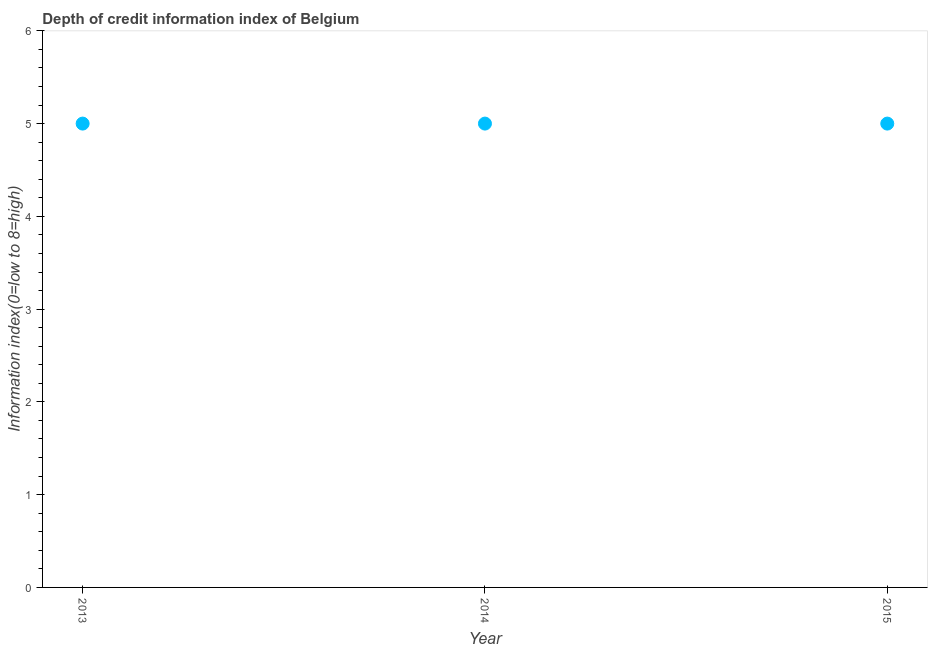What is the depth of credit information index in 2014?
Provide a succinct answer. 5. Across all years, what is the maximum depth of credit information index?
Your answer should be very brief. 5. Across all years, what is the minimum depth of credit information index?
Your answer should be very brief. 5. In which year was the depth of credit information index maximum?
Offer a very short reply. 2013. In which year was the depth of credit information index minimum?
Keep it short and to the point. 2013. What is the sum of the depth of credit information index?
Provide a succinct answer. 15. What is the median depth of credit information index?
Provide a short and direct response. 5. In how many years, is the depth of credit information index greater than 3.4 ?
Keep it short and to the point. 3. Do a majority of the years between 2014 and 2013 (inclusive) have depth of credit information index greater than 3.2 ?
Your answer should be compact. No. Is the depth of credit information index in 2013 less than that in 2014?
Your answer should be compact. No. Is the difference between the depth of credit information index in 2014 and 2015 greater than the difference between any two years?
Your answer should be very brief. Yes. What is the difference between the highest and the second highest depth of credit information index?
Keep it short and to the point. 0. Is the sum of the depth of credit information index in 2013 and 2014 greater than the maximum depth of credit information index across all years?
Give a very brief answer. Yes. How many dotlines are there?
Your answer should be very brief. 1. Are the values on the major ticks of Y-axis written in scientific E-notation?
Make the answer very short. No. Does the graph contain any zero values?
Keep it short and to the point. No. What is the title of the graph?
Provide a succinct answer. Depth of credit information index of Belgium. What is the label or title of the X-axis?
Keep it short and to the point. Year. What is the label or title of the Y-axis?
Give a very brief answer. Information index(0=low to 8=high). What is the Information index(0=low to 8=high) in 2013?
Make the answer very short. 5. What is the Information index(0=low to 8=high) in 2015?
Keep it short and to the point. 5. What is the difference between the Information index(0=low to 8=high) in 2013 and 2014?
Offer a terse response. 0. What is the difference between the Information index(0=low to 8=high) in 2013 and 2015?
Make the answer very short. 0. What is the difference between the Information index(0=low to 8=high) in 2014 and 2015?
Keep it short and to the point. 0. What is the ratio of the Information index(0=low to 8=high) in 2014 to that in 2015?
Provide a succinct answer. 1. 